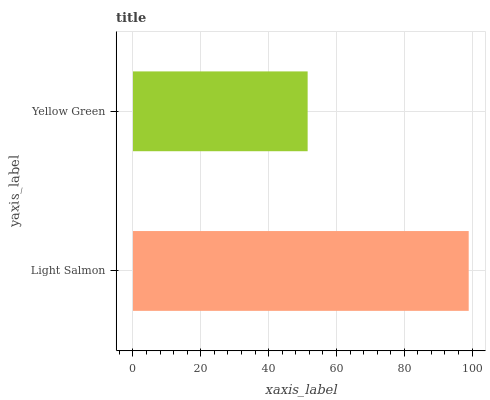Is Yellow Green the minimum?
Answer yes or no. Yes. Is Light Salmon the maximum?
Answer yes or no. Yes. Is Yellow Green the maximum?
Answer yes or no. No. Is Light Salmon greater than Yellow Green?
Answer yes or no. Yes. Is Yellow Green less than Light Salmon?
Answer yes or no. Yes. Is Yellow Green greater than Light Salmon?
Answer yes or no. No. Is Light Salmon less than Yellow Green?
Answer yes or no. No. Is Light Salmon the high median?
Answer yes or no. Yes. Is Yellow Green the low median?
Answer yes or no. Yes. Is Yellow Green the high median?
Answer yes or no. No. Is Light Salmon the low median?
Answer yes or no. No. 